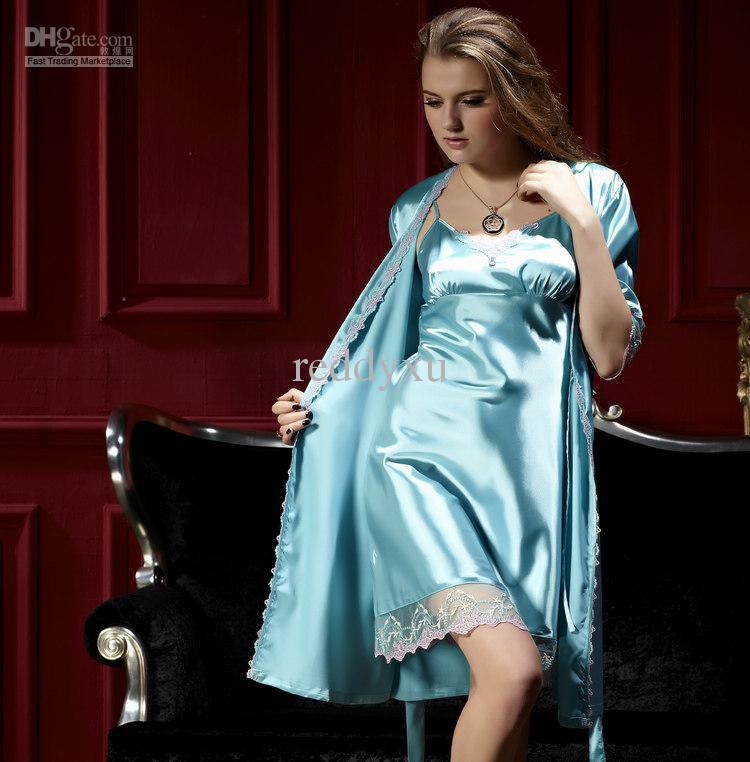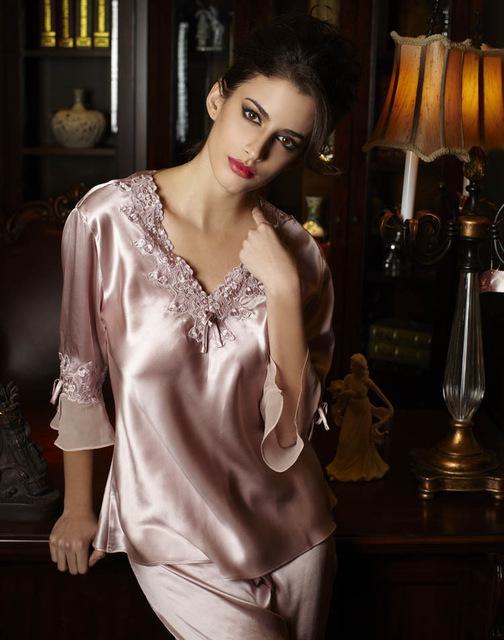The first image is the image on the left, the second image is the image on the right. Considering the images on both sides, is "The model on the left wears matching short-sleeve pajama top and capri-length bottoms, and the model on the right wears a robe over a spaghetti-strap gown." valid? Answer yes or no. No. The first image is the image on the left, the second image is the image on the right. Given the left and right images, does the statement "Pajama pants in one image are knee length with lace edging, topped with a pajama shirt with tie belt at the waist." hold true? Answer yes or no. No. 